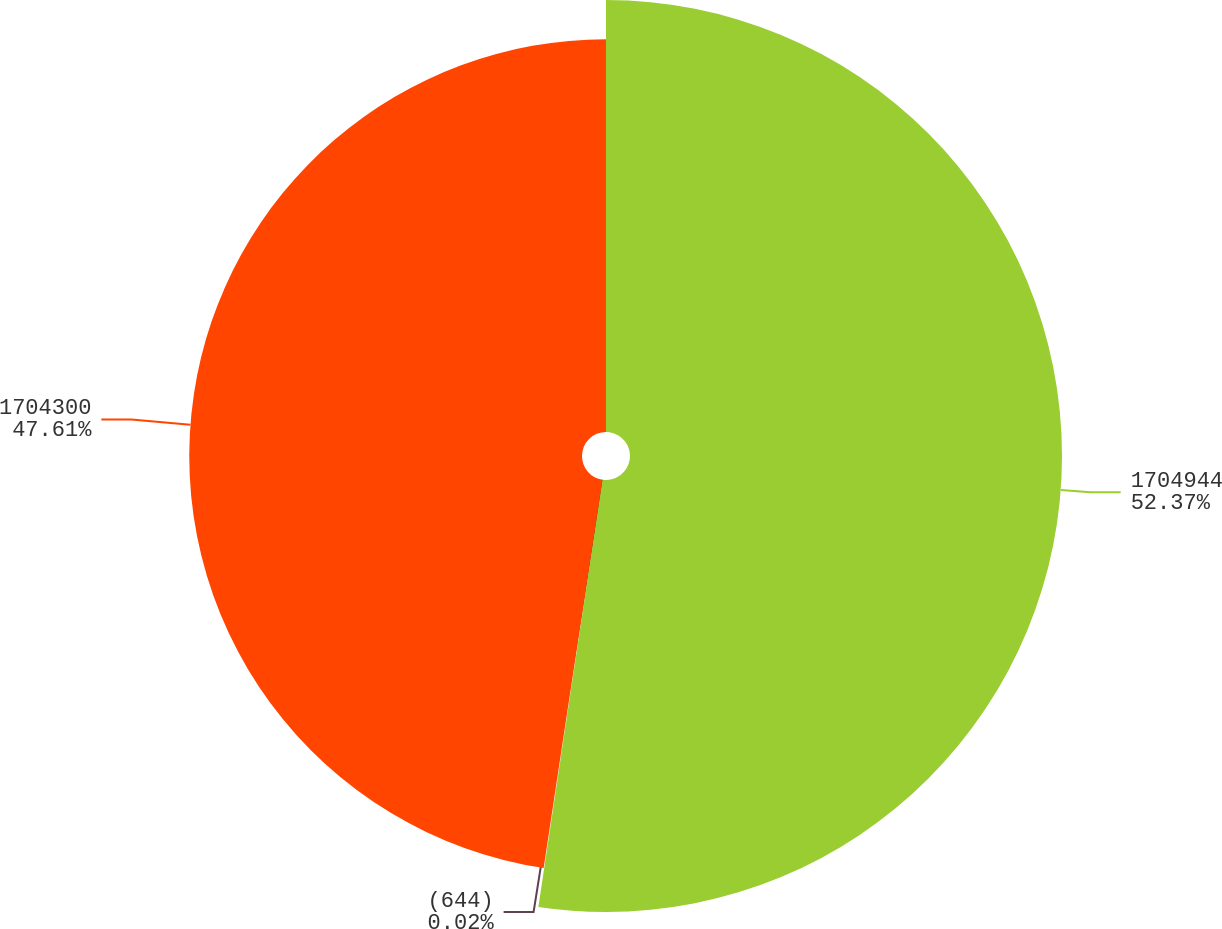<chart> <loc_0><loc_0><loc_500><loc_500><pie_chart><fcel>1704944<fcel>(644)<fcel>1704300<nl><fcel>52.37%<fcel>0.02%<fcel>47.61%<nl></chart> 